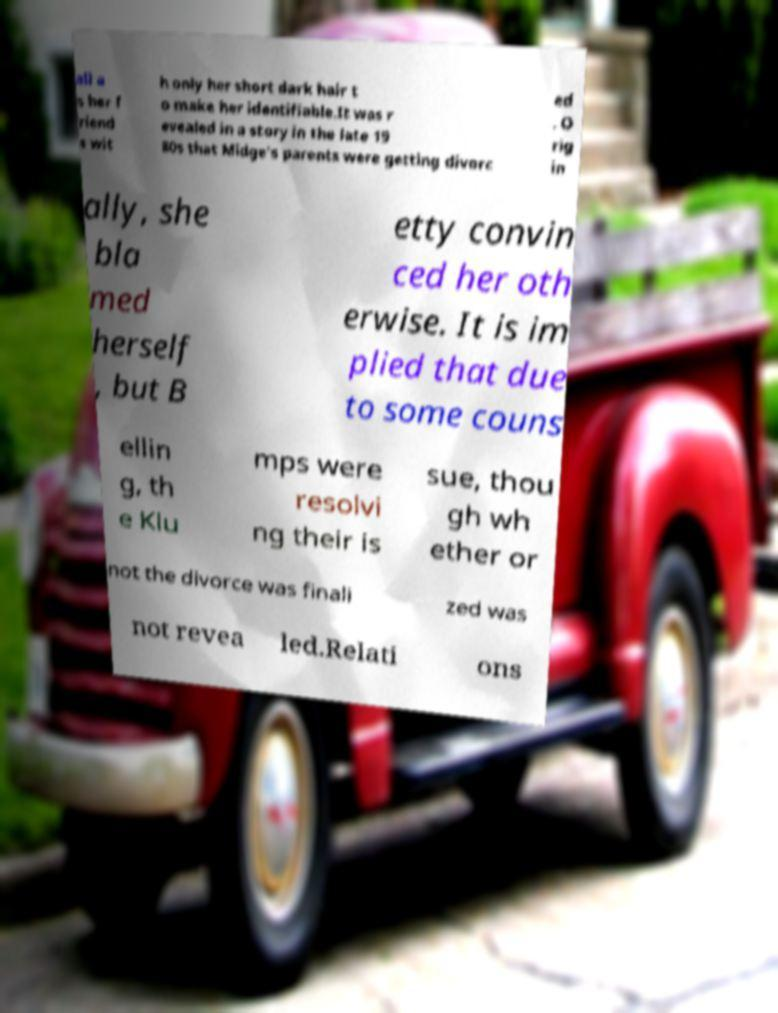Can you accurately transcribe the text from the provided image for me? all a s her f riend s wit h only her short dark hair t o make her identifiable.It was r evealed in a story in the late 19 80s that Midge's parents were getting divorc ed . O rig in ally, she bla med herself , but B etty convin ced her oth erwise. It is im plied that due to some couns ellin g, th e Klu mps were resolvi ng their is sue, thou gh wh ether or not the divorce was finali zed was not revea led.Relati ons 